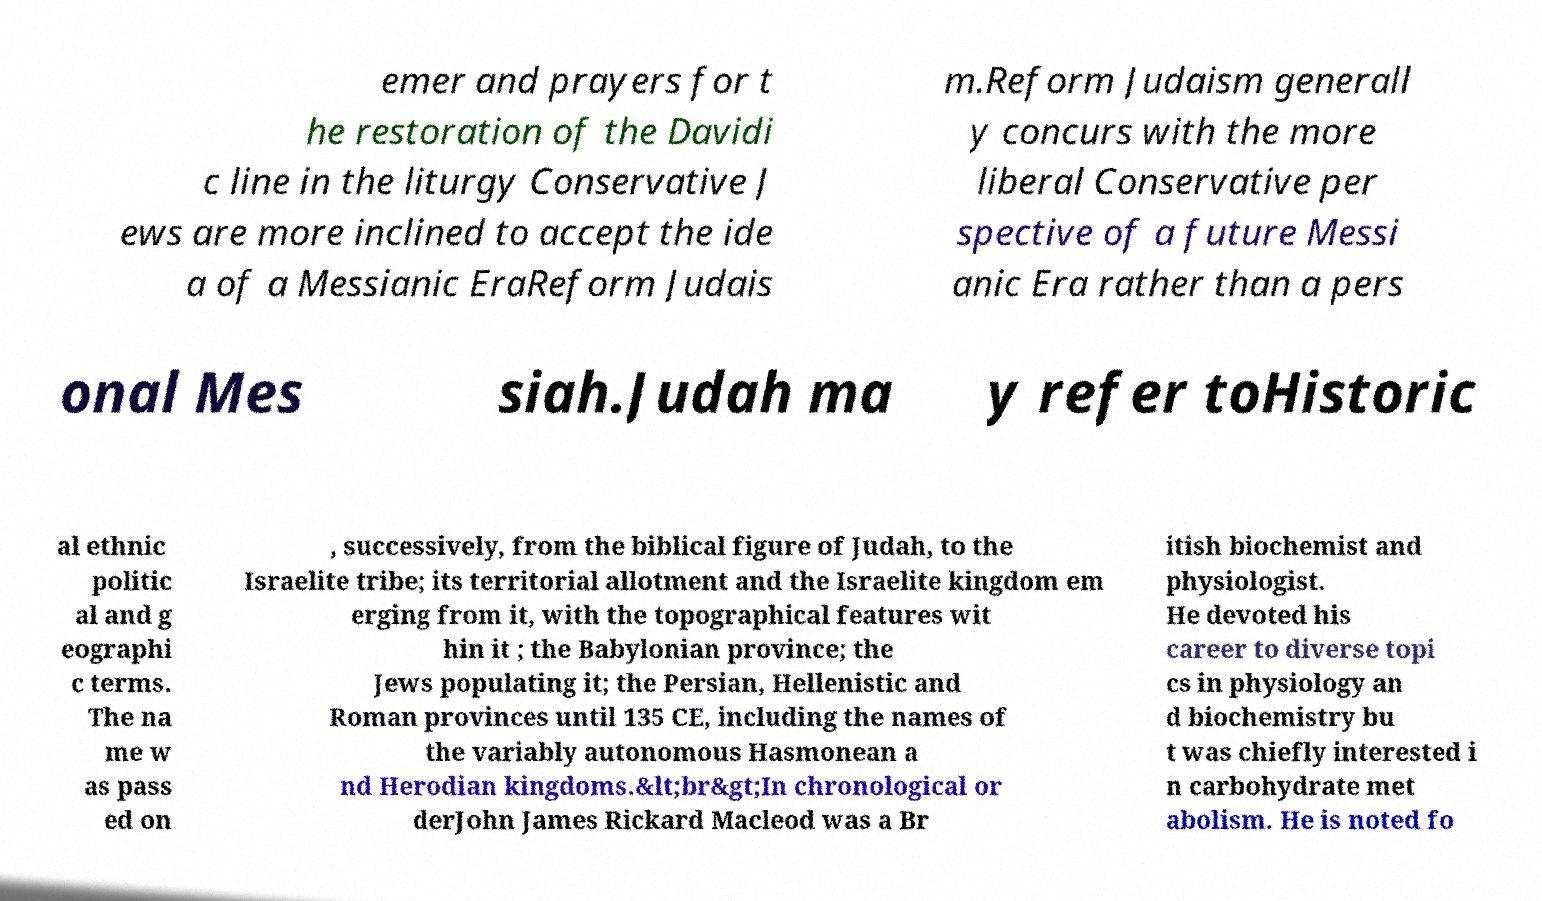For documentation purposes, I need the text within this image transcribed. Could you provide that? emer and prayers for t he restoration of the Davidi c line in the liturgy Conservative J ews are more inclined to accept the ide a of a Messianic EraReform Judais m.Reform Judaism generall y concurs with the more liberal Conservative per spective of a future Messi anic Era rather than a pers onal Mes siah.Judah ma y refer toHistoric al ethnic politic al and g eographi c terms. The na me w as pass ed on , successively, from the biblical figure of Judah, to the Israelite tribe; its territorial allotment and the Israelite kingdom em erging from it, with the topographical features wit hin it ; the Babylonian province; the Jews populating it; the Persian, Hellenistic and Roman provinces until 135 CE, including the names of the variably autonomous Hasmonean a nd Herodian kingdoms.&lt;br&gt;In chronological or derJohn James Rickard Macleod was a Br itish biochemist and physiologist. He devoted his career to diverse topi cs in physiology an d biochemistry bu t was chiefly interested i n carbohydrate met abolism. He is noted fo 